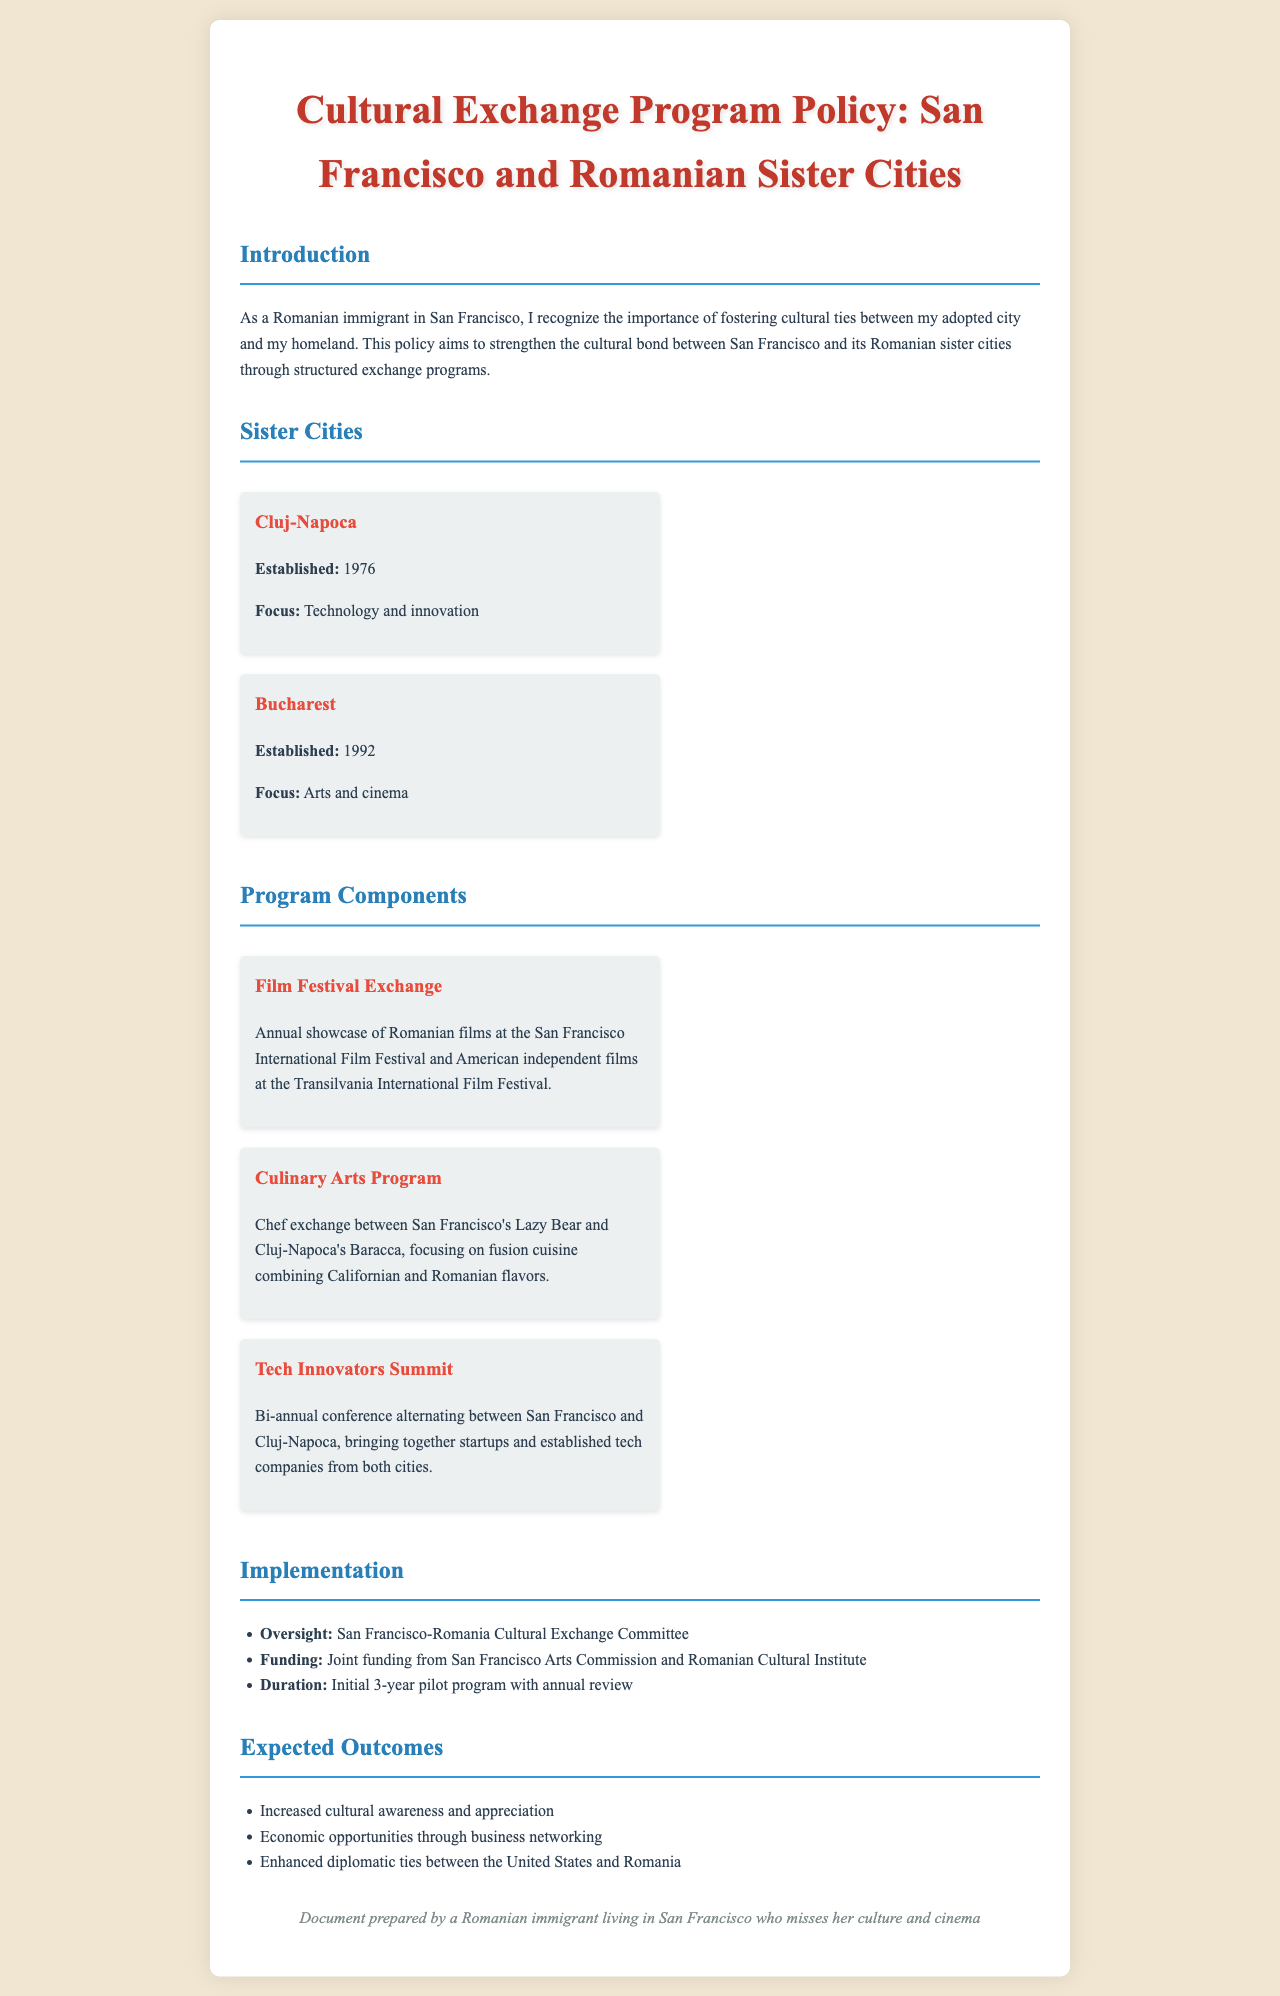what are the names of the sister cities? The document lists Cluj-Napoca and Bucharest as the sister cities of San Francisco.
Answer: Cluj-Napoca, Bucharest when was Cluj-Napoca established as a sister city? The establishment date of Cluj-Napoca as a sister city is mentioned in the document.
Answer: 1976 what is the main focus of the cultural exchange program with Bucharest? The document specifies that the focus of the program with Bucharest is on arts and cinema.
Answer: Arts and cinema how often does the Tech Innovators Summit occur? The document states the frequency of the Tech Innovators Summit in relation to the two cities.
Answer: Bi-annual who oversees the cultural exchange program? The document identifies the committee responsible for overseeing the program.
Answer: San Francisco-Romania Cultural Exchange Committee what is the initial duration of the pilot program? The document explicitly mentions the initial duration planned for this program.
Answer: 3 years which two culinary establishments are involved in the Culinary Arts Program? The document lists the names of the two establishments that participate in the culinary exchange.
Answer: Lazy Bear, Baracca what is one expected outcome of the program? The document lists several expected outcomes from the cultural exchange program.
Answer: Increased cultural awareness and appreciation 